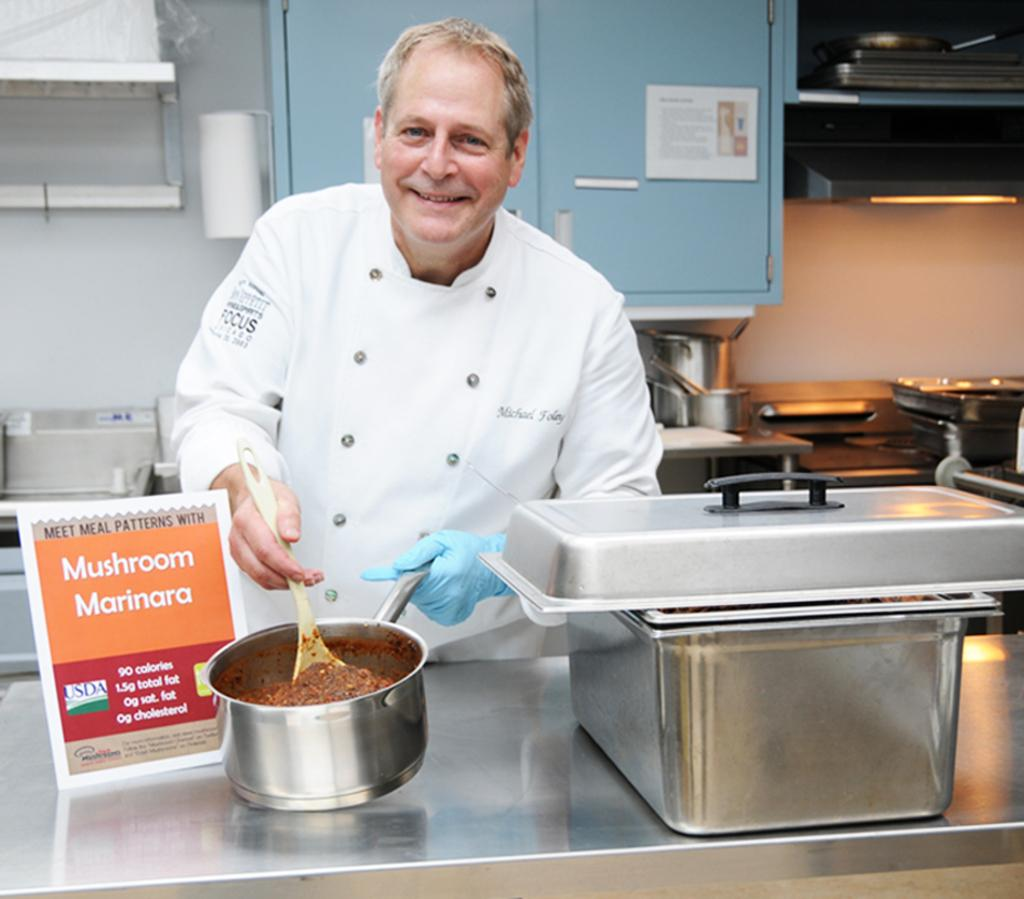<image>
Write a terse but informative summary of the picture. A smiling chef displays a pot of mushroom marinara sauce. 